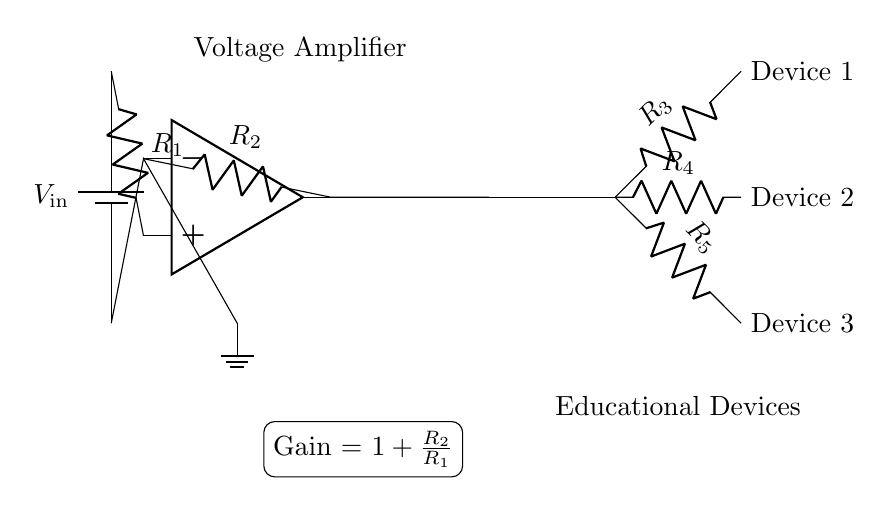What is the input voltage in this circuit? The input voltage is represented as \( V_\text{in} \) from the battery at the top of the circuit diagram.
Answer: V_in What is the purpose of the resistors R1 and R2? Resistor R1 is used to control the input to the amplifier, while R2 is the feedback resistor that sets the gain of the amplifier.
Answer: Control and gain What is the amplifier's gain formula? The gain of the amplifier is shown in the circuit as \( 1 + \frac{R_2}{R_1} \), indicating the relationship between the feedback and input resistances in determining amplification.
Answer: 1 + R2/R1 How many educational devices can be powered simultaneously? The circuit shows three resistors labeled as Device 1, Device 2, and Device 3, indicating that three educational devices can be powered simultaneously.
Answer: Three What indicates that this is a voltage amplifier circuit? The presence of an operational amplifier (op amp) and the gain equation typical for voltage amplifiers suggest this is a voltage amplifier circuit.
Answer: Operational amplifier What connection allows for multiple devices' operations? The distribution network directly connected to the output of the amplifier, with resistors connecting to each educational device, allows them to operate simultaneously.
Answer: Distribution network What role does R3, R4, and R5 play in this circuit? R3, R4, and R5 act as current limiters for each educational device, controlling the voltage drop across each device to ensure they operate safely.
Answer: Current limiting 